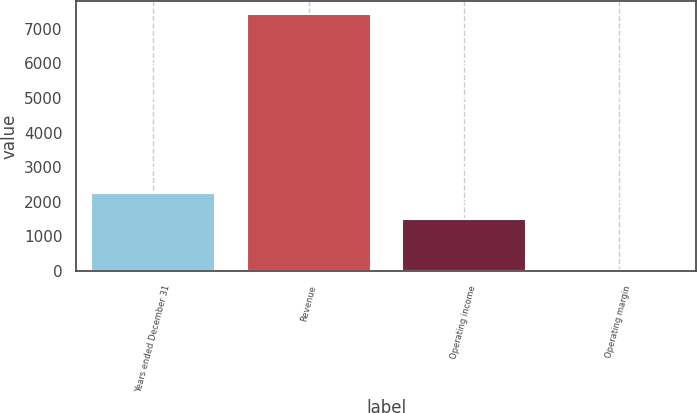<chart> <loc_0><loc_0><loc_500><loc_500><bar_chart><fcel>Years ended December 31<fcel>Revenue<fcel>Operating income<fcel>Operating margin<nl><fcel>2246.57<fcel>7426<fcel>1506<fcel>20.3<nl></chart> 